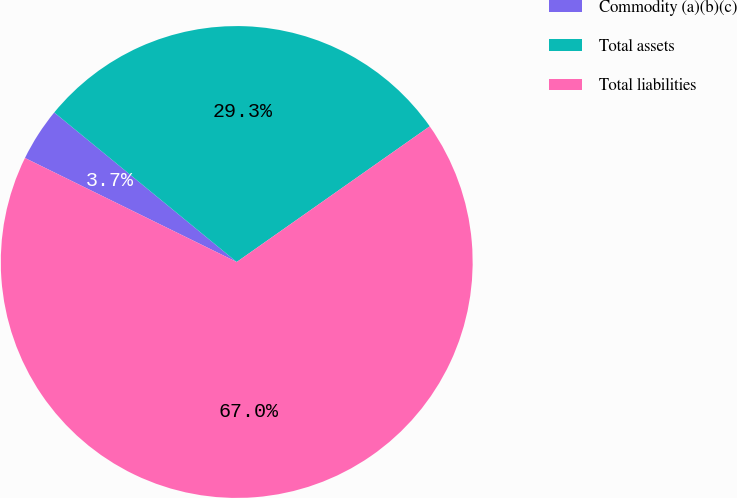<chart> <loc_0><loc_0><loc_500><loc_500><pie_chart><fcel>Commodity (a)(b)(c)<fcel>Total assets<fcel>Total liabilities<nl><fcel>3.66%<fcel>29.32%<fcel>67.02%<nl></chart> 